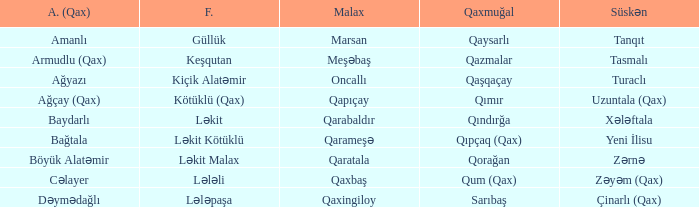What is the Almali village with the Malax village qaxingiloy? Dəymədağlı. 